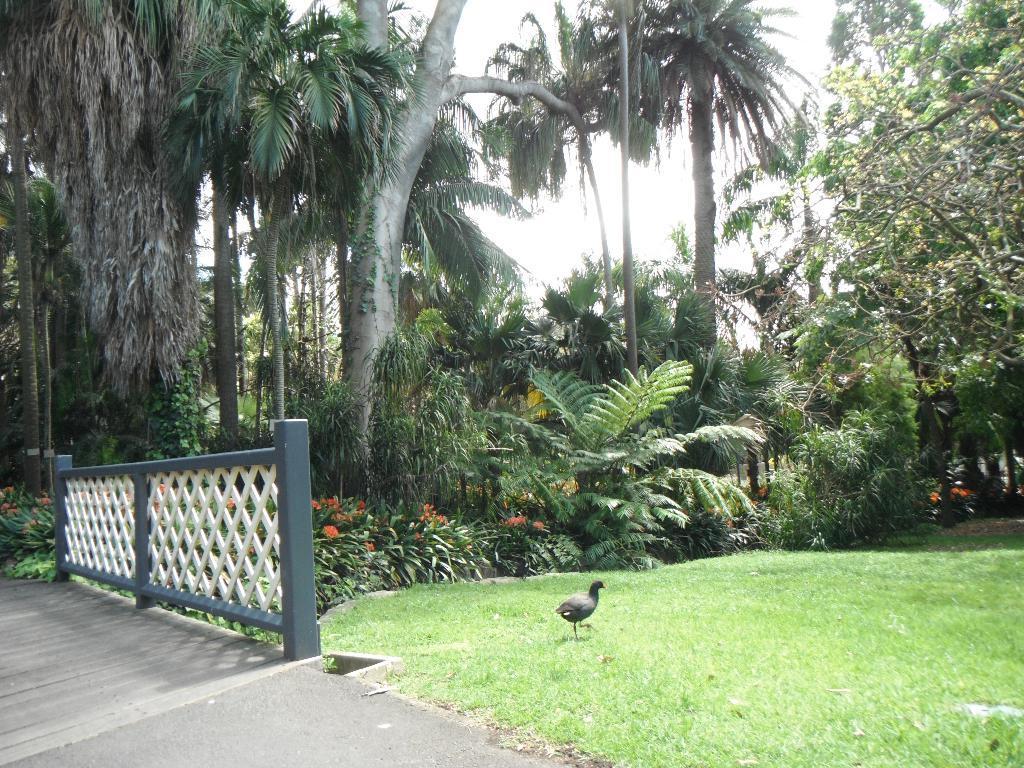Could you give a brief overview of what you see in this image? In this image I can see a bird is walking on the grass. Here I can see a fence. In the background I can see trees, plants and the sky. 